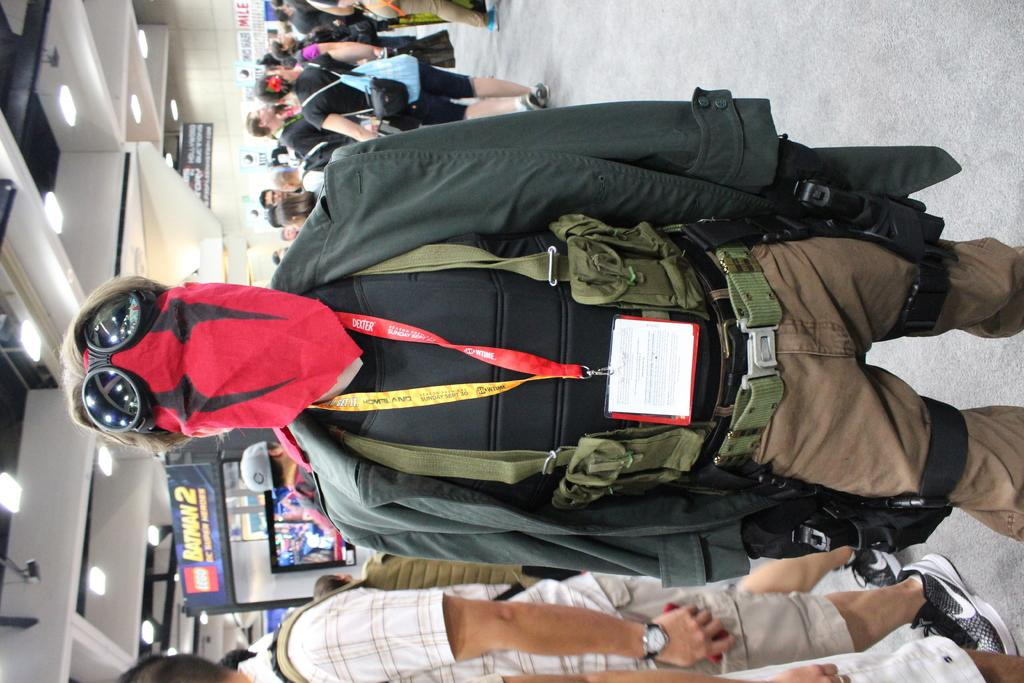Provide a one-sentence caption for the provided image. A man wearing a red face mask stands near a Lego Batman 2 display. 